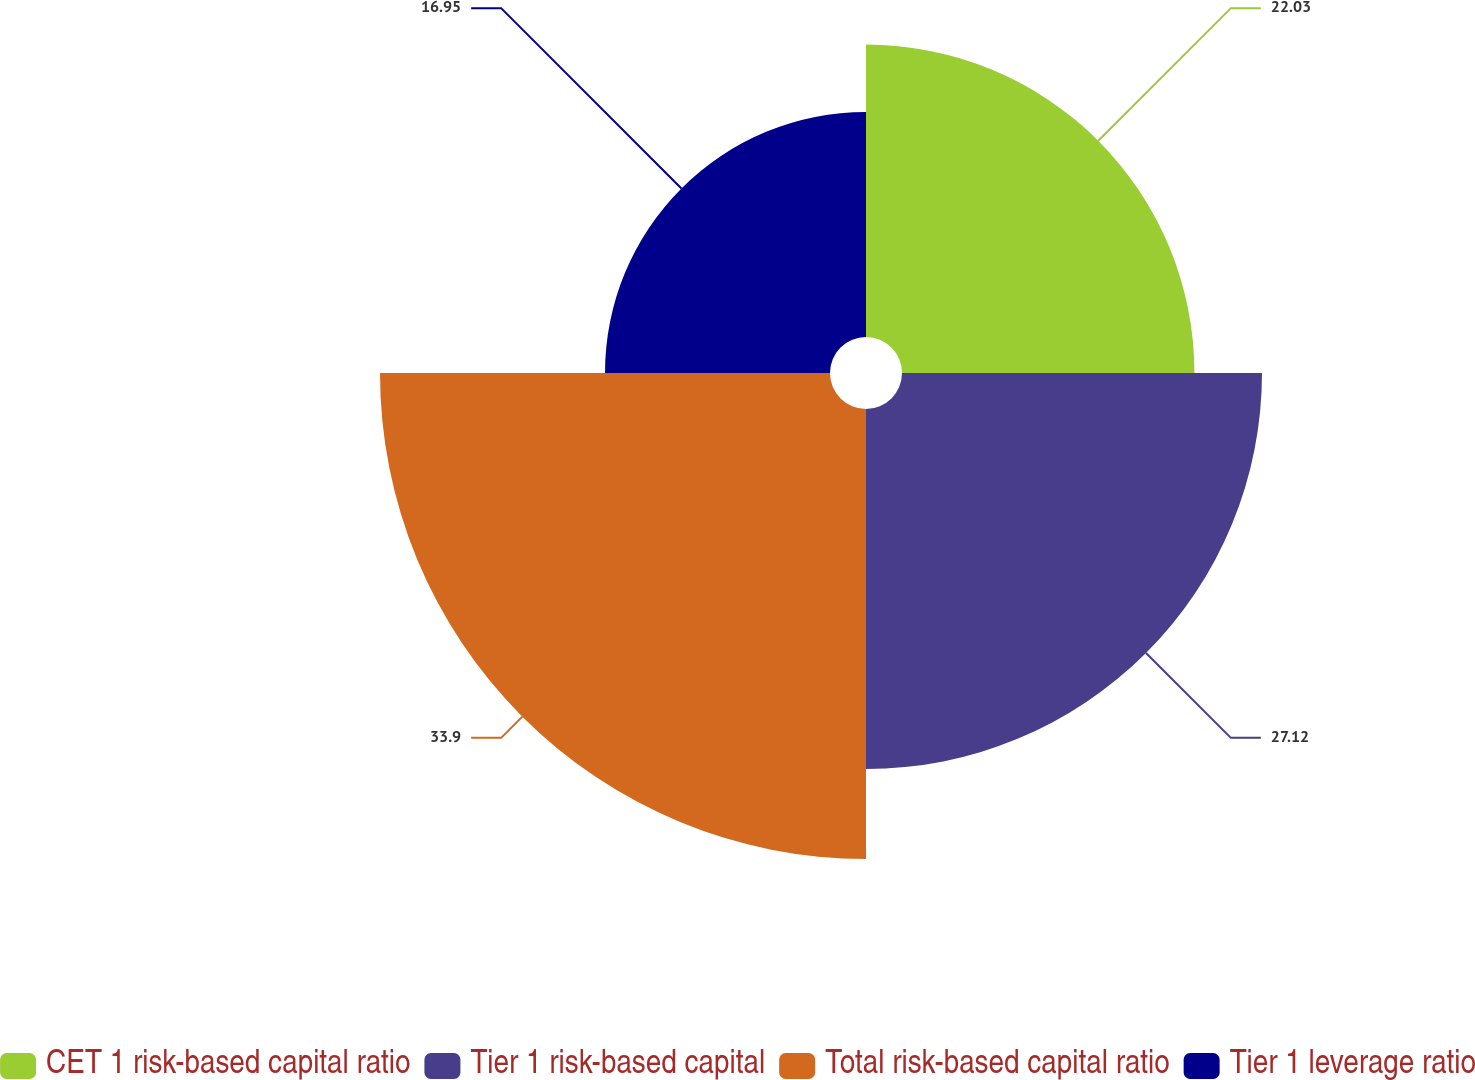Convert chart to OTSL. <chart><loc_0><loc_0><loc_500><loc_500><pie_chart><fcel>CET 1 risk-based capital ratio<fcel>Tier 1 risk-based capital<fcel>Total risk-based capital ratio<fcel>Tier 1 leverage ratio<nl><fcel>22.03%<fcel>27.12%<fcel>33.9%<fcel>16.95%<nl></chart> 